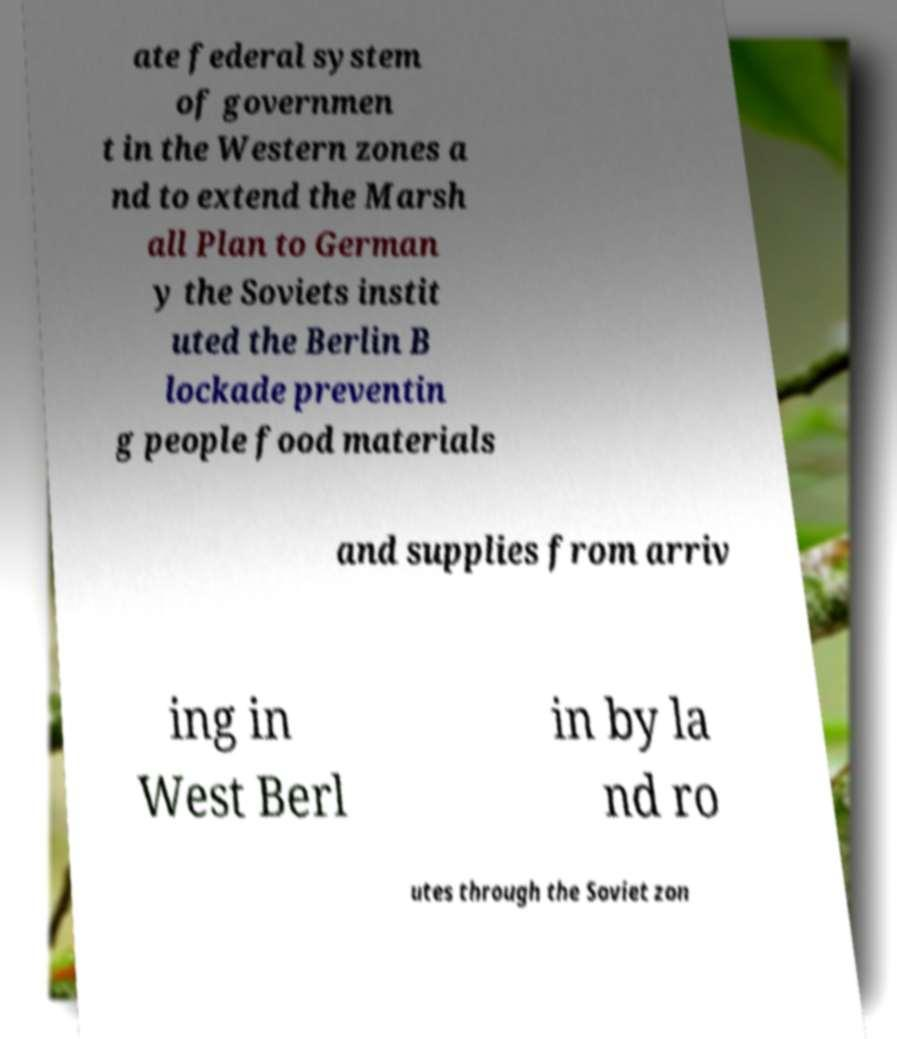I need the written content from this picture converted into text. Can you do that? ate federal system of governmen t in the Western zones a nd to extend the Marsh all Plan to German y the Soviets instit uted the Berlin B lockade preventin g people food materials and supplies from arriv ing in West Berl in by la nd ro utes through the Soviet zon 